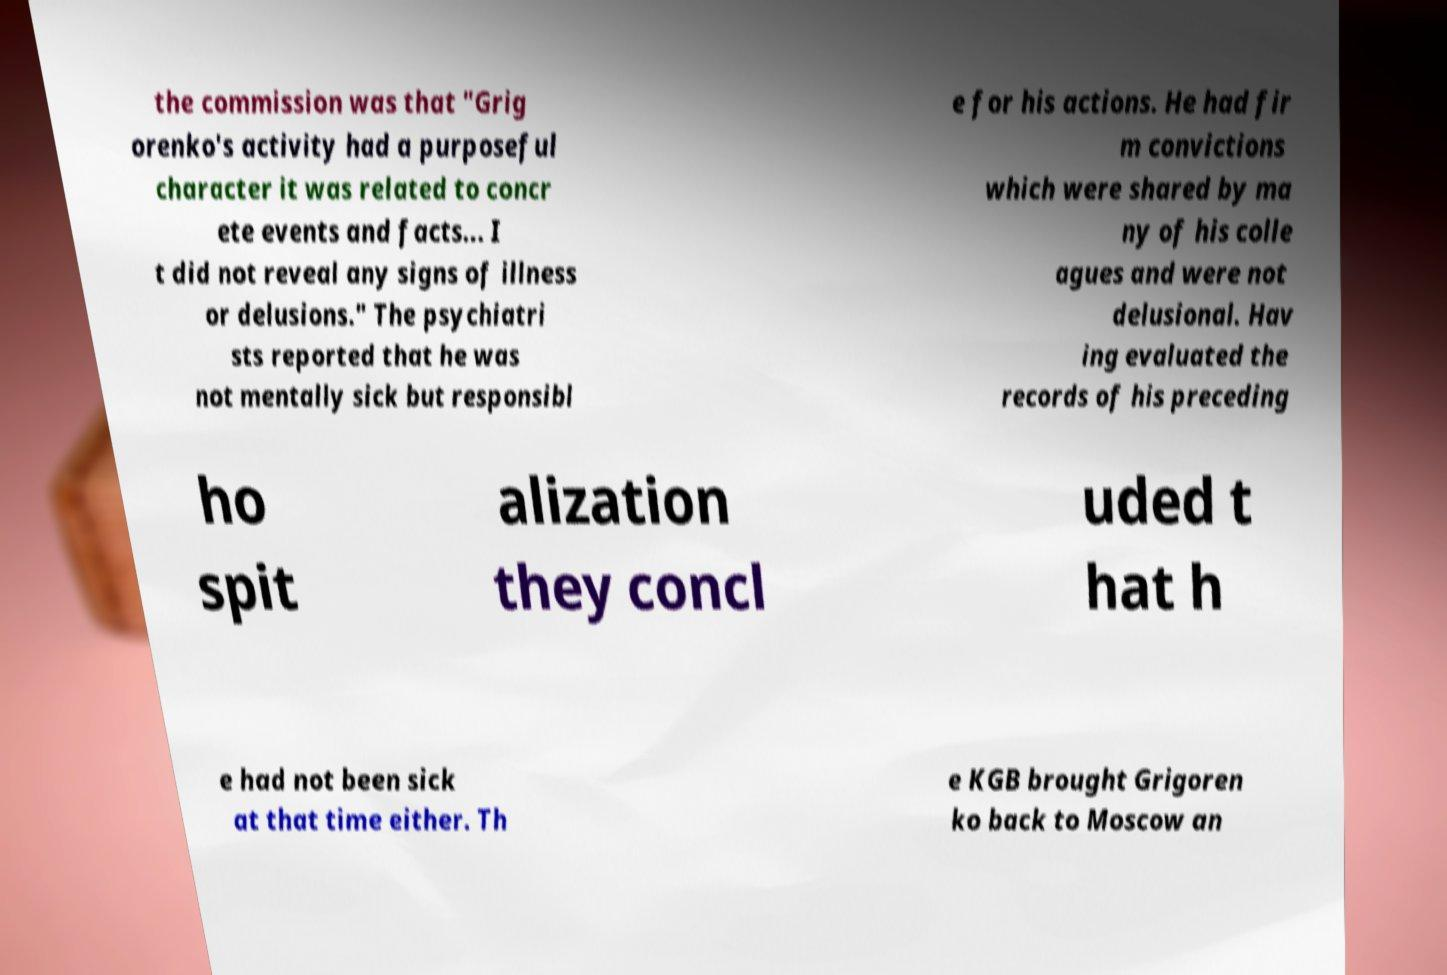Can you accurately transcribe the text from the provided image for me? the commission was that "Grig orenko's activity had a purposeful character it was related to concr ete events and facts... I t did not reveal any signs of illness or delusions." The psychiatri sts reported that he was not mentally sick but responsibl e for his actions. He had fir m convictions which were shared by ma ny of his colle agues and were not delusional. Hav ing evaluated the records of his preceding ho spit alization they concl uded t hat h e had not been sick at that time either. Th e KGB brought Grigoren ko back to Moscow an 